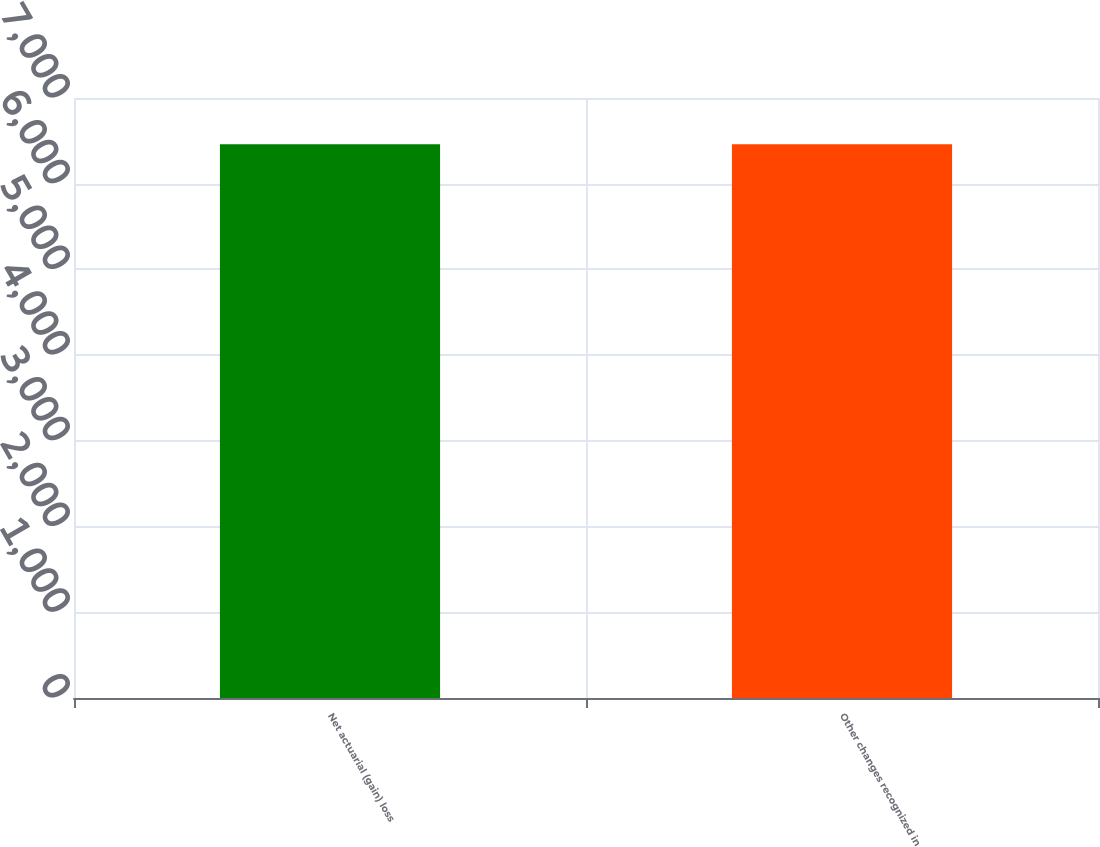Convert chart. <chart><loc_0><loc_0><loc_500><loc_500><bar_chart><fcel>Net actuarial (gain) loss<fcel>Other changes recognized in<nl><fcel>6460<fcel>6460.1<nl></chart> 